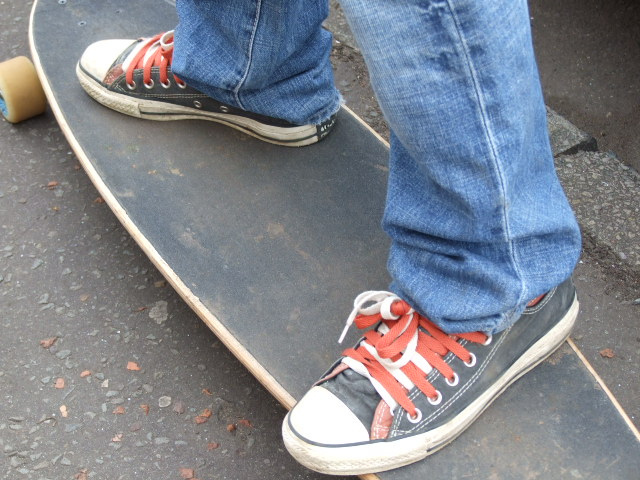What company created the shoes the person is wearing? The shoes worn by the person have the distinctive design of Converse, recognizable by the classic white toe cap, rubber sole, and the star-centered patch that symbolizes this iconic brand. 